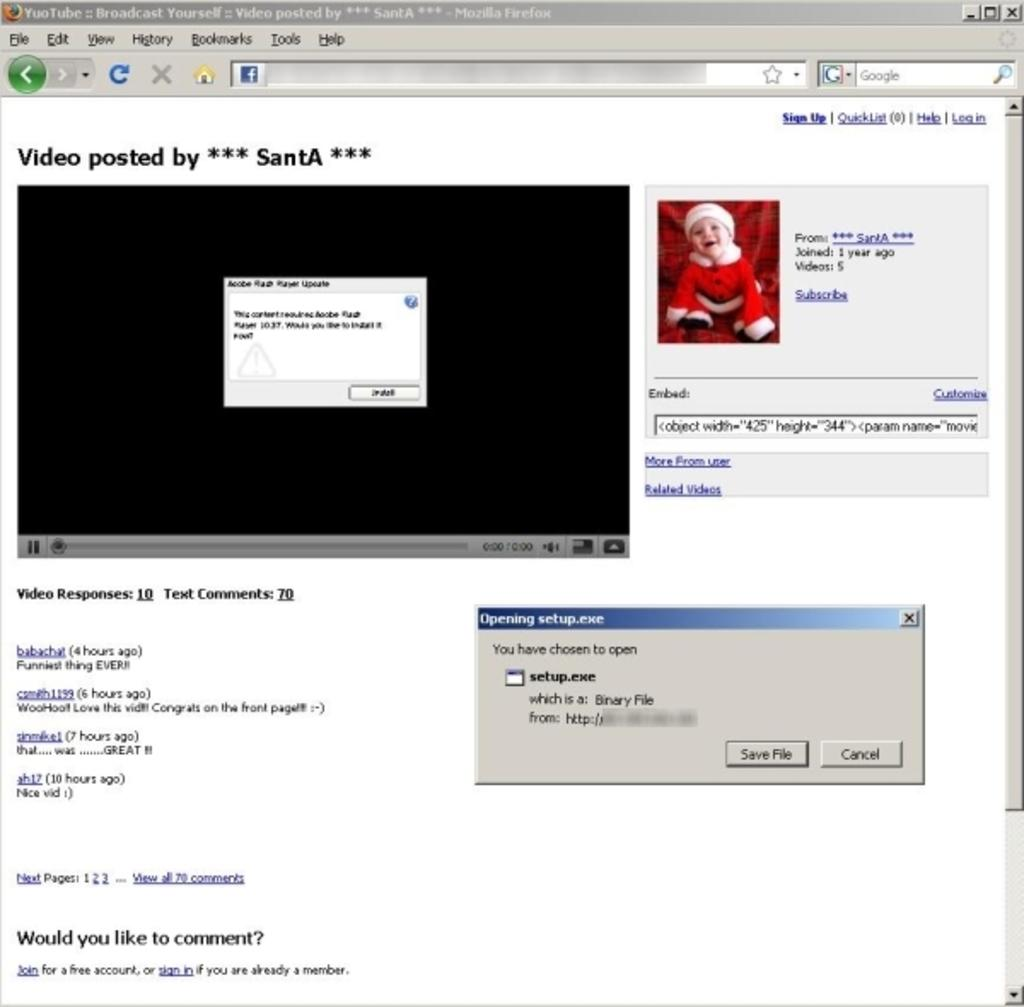<image>
Describe the image concisely. A computer screen with a video posted by *** SantA *** displayed. 